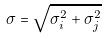Convert formula to latex. <formula><loc_0><loc_0><loc_500><loc_500>\sigma = \sqrt { \sigma _ { i } ^ { 2 } + \sigma _ { j } ^ { 2 } }</formula> 